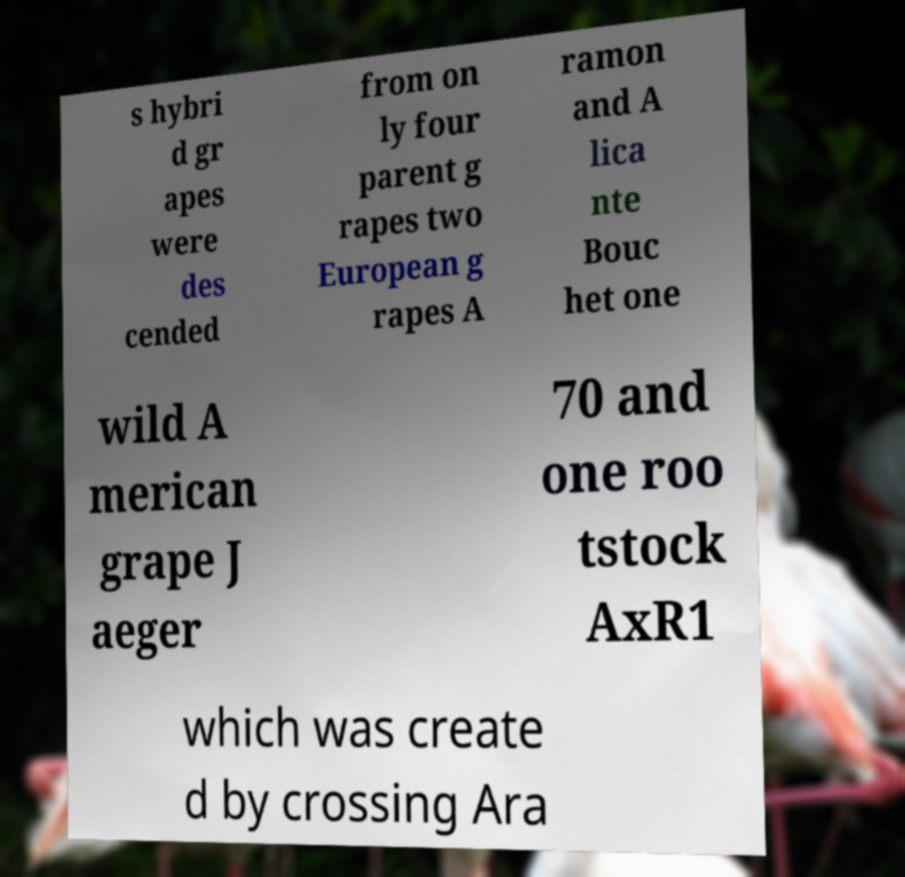Can you accurately transcribe the text from the provided image for me? s hybri d gr apes were des cended from on ly four parent g rapes two European g rapes A ramon and A lica nte Bouc het one wild A merican grape J aeger 70 and one roo tstock AxR1 which was create d by crossing Ara 